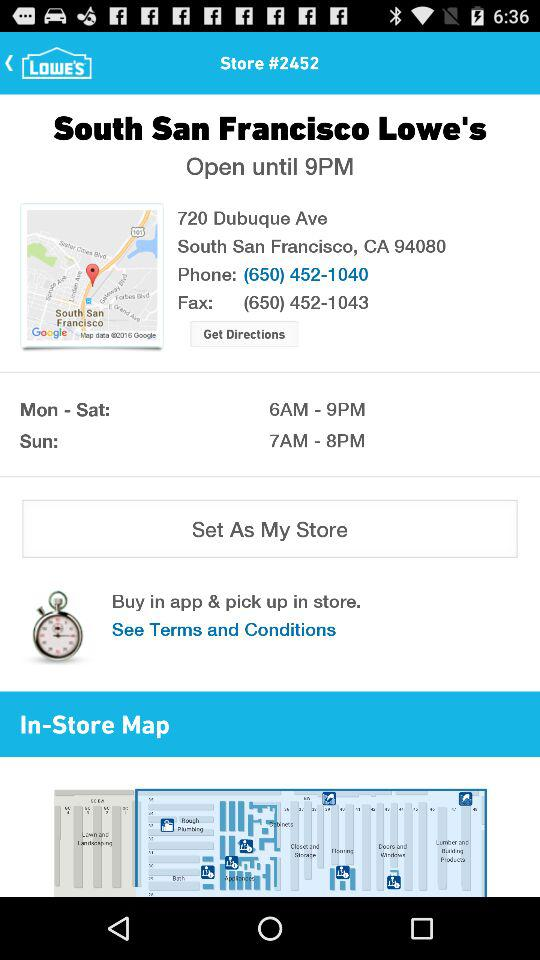What is the fax number? The fax number is (650) 452-1043. 